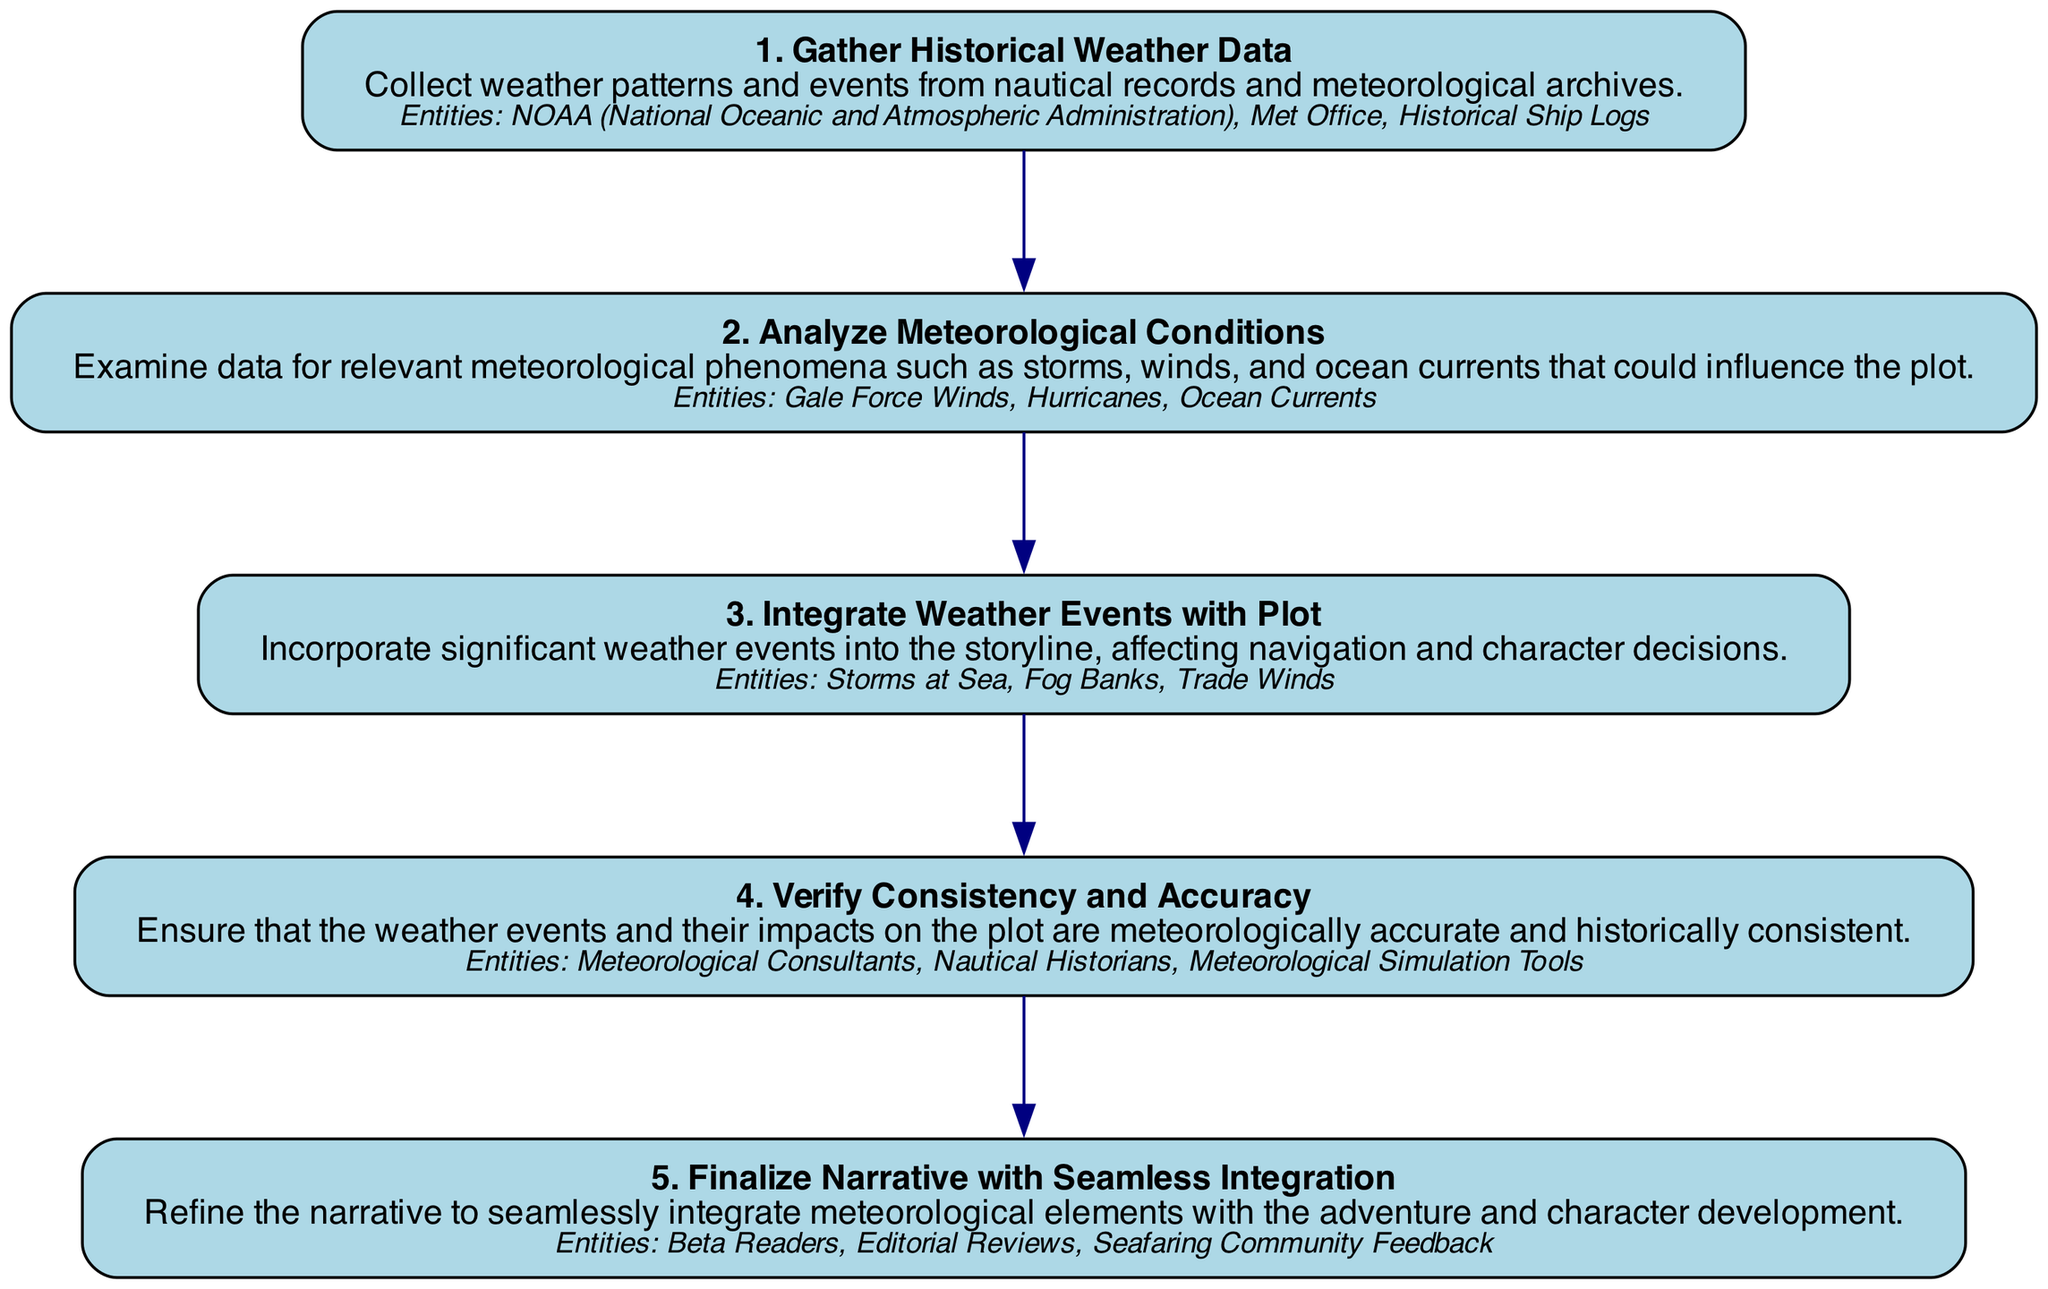What is the first step in the process? The first step in the diagram is explicitly labeled as "1" and is titled "Gather Historical Weather Data." This indicates that it is the starting point for the entire process described.
Answer: Gather Historical Weather Data How many nodes are present in the diagram? By counting the steps outlined in the diagram from "1" to "5," we see there are five distinct steps that correspond to five nodes.
Answer: 5 What is the title of the third step? The diagram clearly states that the title for the third step is "Integrate Weather Events with Plot." Therefore, this is the specific title sought for that step.
Answer: Integrate Weather Events with Plot What entities are listed under the second step? Under the second step "Analyze Meteorological Conditions," the entities listed are "Gale Force Winds," "Hurricanes," and "Ocean Currents." This is verified by looking specifically at that node's details in the diagram.
Answer: Gale Force Winds, Hurricanes, Ocean Currents Which step comes immediately after "Analyze Meteorological Conditions"? The diagram indicates that after the second step, "Analyze Meteorological Conditions" (step 2), the next sequential step is "Integrate Weather Events with Plot" (step 3). This relationship is defined by the flow of the directed graph.
Answer: Integrate Weather Events with Plot What is the main focus of step 4? Step 4, titled "Verify Consistency and Accuracy," focuses on ensuring meteorological accuracy and consistency within the narrative plot. This is determined by analyzing the title and description provided for that step.
Answer: Verify Consistency and Accuracy Identify one of the entities associated with the final step. The fifth step, "Finalize Narrative with Seamless Integration," includes entities such as "Beta Readers," "Editorial Reviews," or "Seafaring Community Feedback." Any one of these entities represents information related to this step.
Answer: Beta Readers What is the relationship between step 3 and step 4? Step 3 culminates in introducing weather events into the plot, and step 4 continues from there by verifying the accuracy of those events. The directed edge between these two nodes emphasizes that step 4 follows from the completion of step 3.
Answer: Verify Consistency and Accuracy How many entities are associated with step 5? Step 5 includes three entities, specifically listed as "Beta Readers," "Editorial Reviews," and "Seafaring Community Feedback." Counting these gives a total of three unique entities associated with this final step.
Answer: 3 